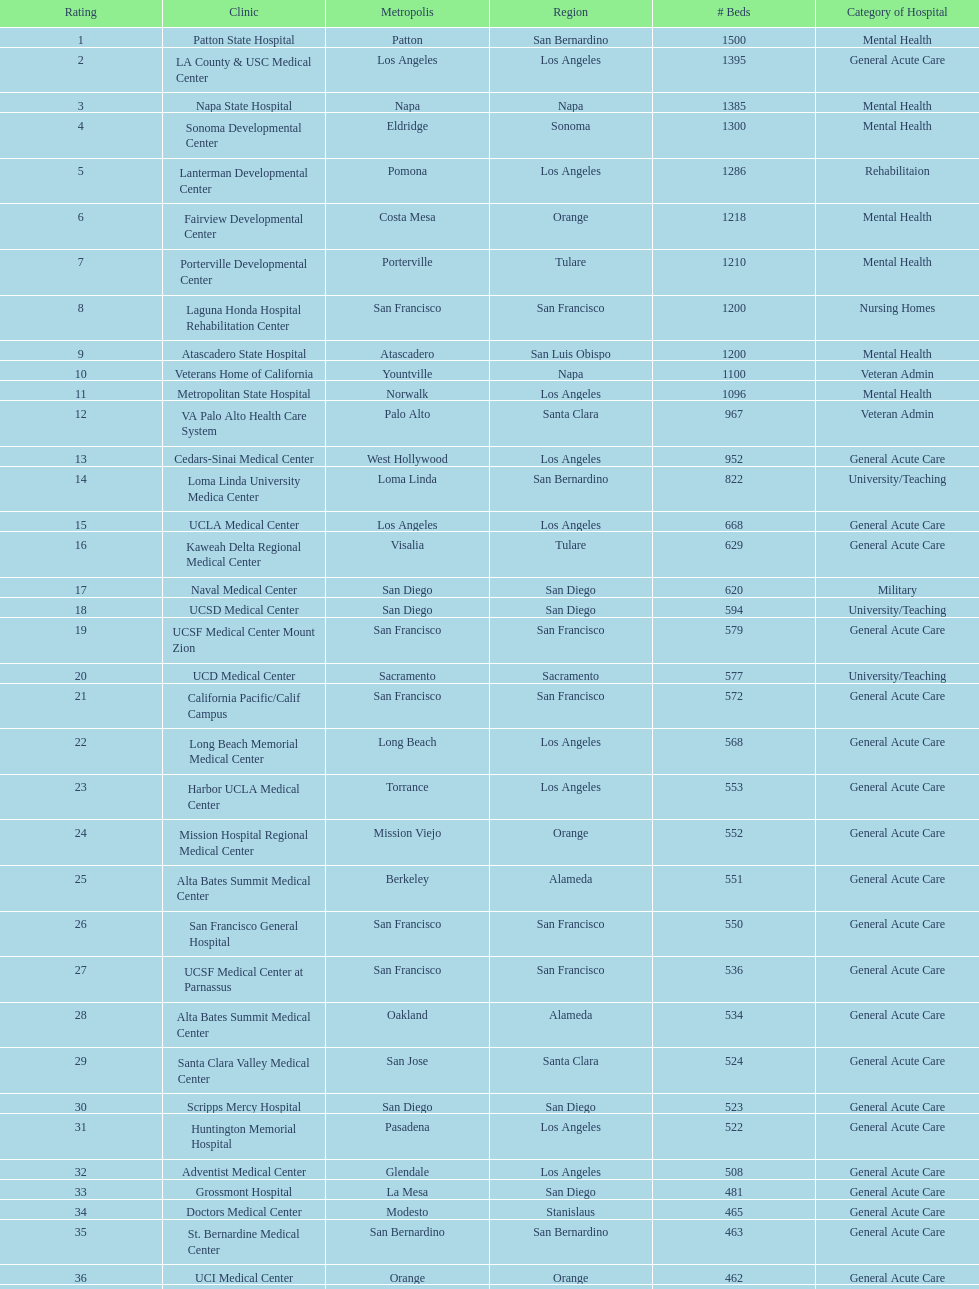In los angeles county, which hospital that provides rehabilitation-focused beds is ranked within the top 10 hospitals? Lanterman Developmental Center. 